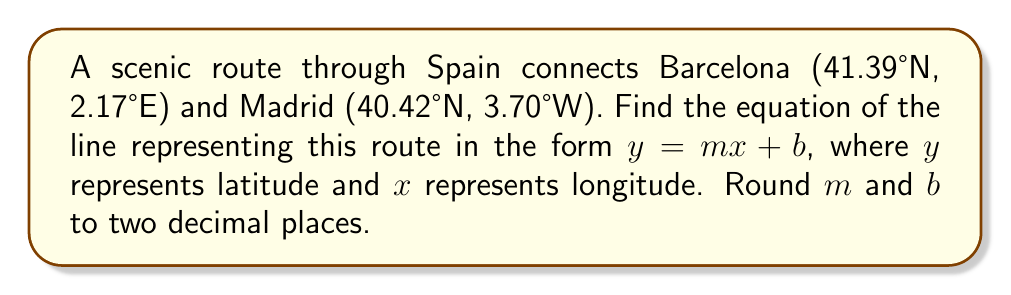Solve this math problem. 1) First, we need to identify our two points:
   Barcelona: $(x_1, y_1) = (2.17, 41.39)$
   Madrid: $(x_2, y_2) = (-3.70, 40.42)$

2) Calculate the slope $(m)$ using the slope formula:
   $$m = \frac{y_2 - y_1}{x_2 - x_1} = \frac{40.42 - 41.39}{-3.70 - 2.17} = \frac{-0.97}{-5.87} \approx 0.17$$

3) Use the point-slope form of a line with Barcelona's coordinates:
   $$y - y_1 = m(x - x_1)$$
   $$y - 41.39 = 0.17(x - 2.17)$$

4) Expand the equation:
   $$y - 41.39 = 0.17x - 0.37$$

5) Solve for $y$ to get the slope-intercept form:
   $$y = 0.17x - 0.37 + 41.39$$
   $$y = 0.17x + 41.02$$

6) Round $m$ and $b$ to two decimal places:
   $$y = 0.17x + 41.02$$
Answer: $y = 0.17x + 41.02$ 